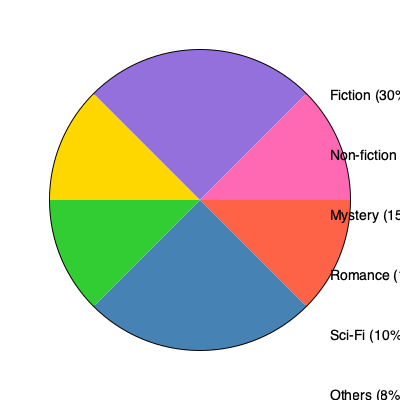As a publisher representative, you're analyzing the market share of different genres in the publishing industry. Based on the pie chart, which two genres combined would represent over 50% of the market share, potentially indicating a lucrative opportunity for classified stories? To answer this question, we need to follow these steps:

1. Identify the market share percentages for each genre:
   - Fiction: 30%
   - Non-fiction: 25%
   - Mystery: 15%
   - Romance: 12%
   - Sci-Fi: 10%
   - Others: 8%

2. Look for combinations of two genres that sum to over 50%:
   - Fiction + Non-fiction = 30% + 25% = 55%
   - Fiction + Mystery = 30% + 15% = 45%
   - Fiction + Romance = 30% + 12% = 42%
   - Fiction + Sci-Fi = 30% + 10% = 40%
   - Non-fiction + Mystery = 25% + 15% = 40%
   - Non-fiction + Romance = 25% + 12% = 37%
   - Non-fiction + Sci-Fi = 25% + 10% = 35%

3. Identify the only combination that exceeds 50%:
   Fiction (30%) and Non-fiction (25%) combine for a total of 55% market share.

4. Consider the relevance to classified stories:
   Both Fiction and Non-fiction genres can accommodate classified stories, making this combination particularly suitable for adapting classified information into bestselling books.
Answer: Fiction and Non-fiction 